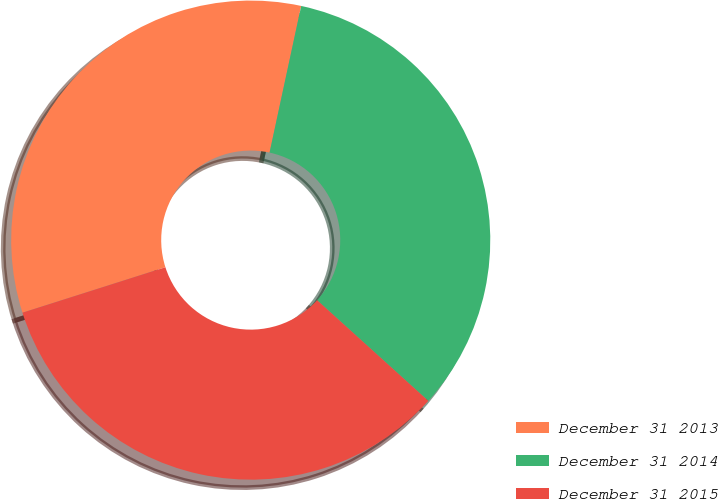<chart> <loc_0><loc_0><loc_500><loc_500><pie_chart><fcel>December 31 2013<fcel>December 31 2014<fcel>December 31 2015<nl><fcel>33.28%<fcel>33.33%<fcel>33.39%<nl></chart> 